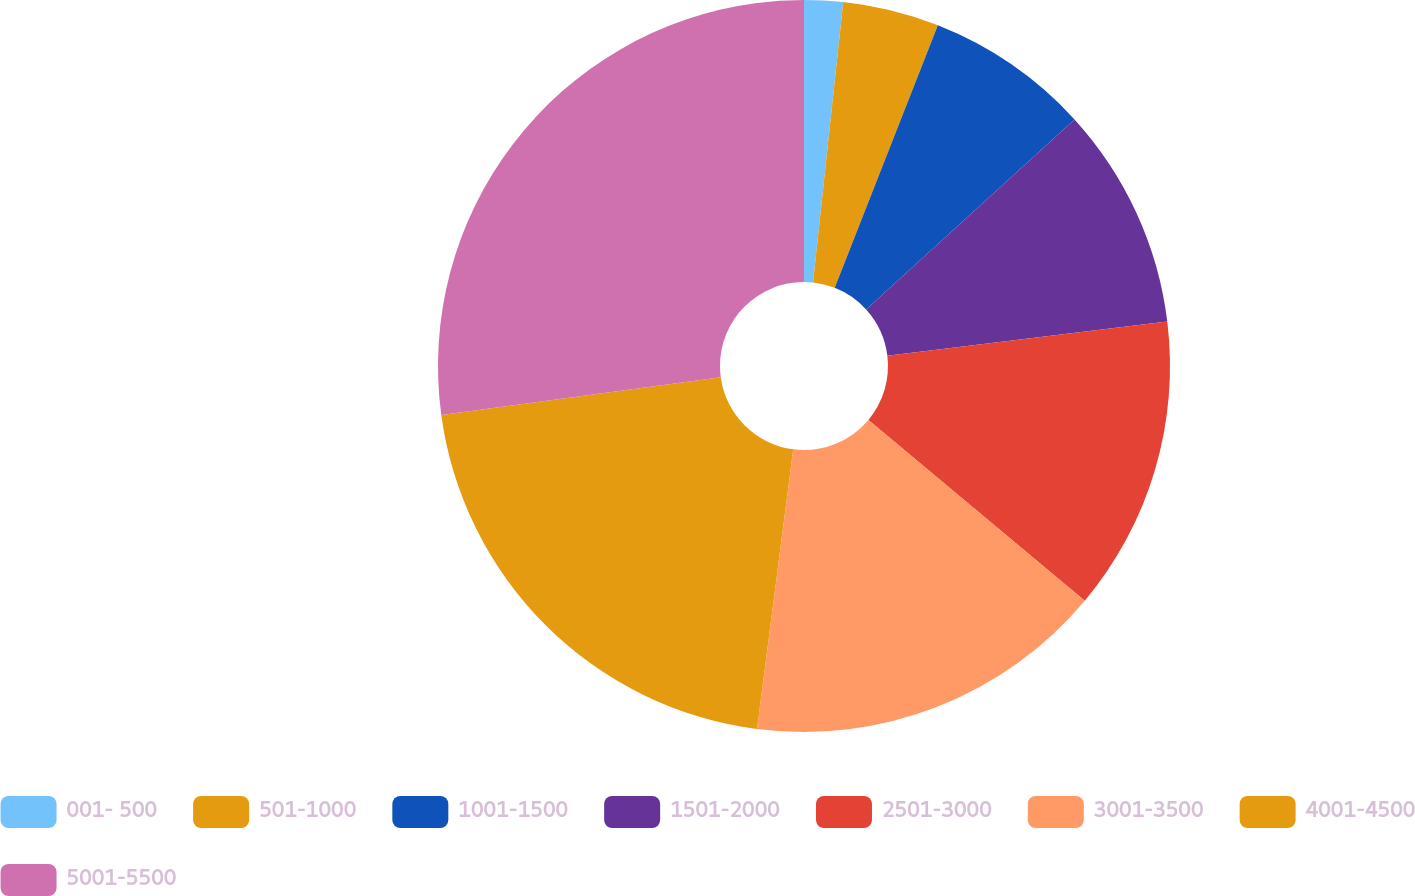Convert chart to OTSL. <chart><loc_0><loc_0><loc_500><loc_500><pie_chart><fcel>001- 500<fcel>501-1000<fcel>1001-1500<fcel>1501-2000<fcel>2501-3000<fcel>3001-3500<fcel>4001-4500<fcel>5001-5500<nl><fcel>1.71%<fcel>4.25%<fcel>7.28%<fcel>9.82%<fcel>13.03%<fcel>15.97%<fcel>20.82%<fcel>27.14%<nl></chart> 